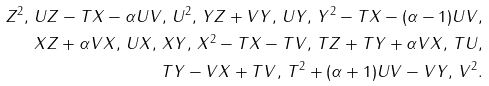Convert formula to latex. <formula><loc_0><loc_0><loc_500><loc_500>Z ^ { 2 } , \, U Z - T X - \alpha U V , \, U ^ { 2 } , \, Y Z + V Y , \, U Y , \, Y ^ { 2 } - T X - ( \alpha - 1 ) U V , \\ X Z + \alpha V X , \, U X , \, X Y , \, X ^ { 2 } - T X - T V , \, T Z + T Y + \alpha V X , \, T U , \\ T Y - V X + T V , \, T ^ { 2 } + ( \alpha + 1 ) U V - V Y , \, V ^ { 2 } .</formula> 